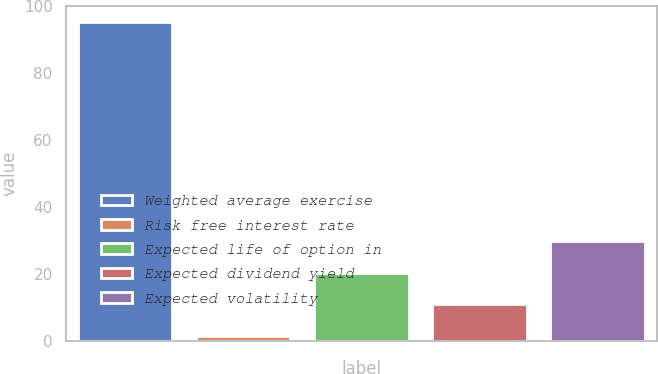Convert chart. <chart><loc_0><loc_0><loc_500><loc_500><bar_chart><fcel>Weighted average exercise<fcel>Risk free interest rate<fcel>Expected life of option in<fcel>Expected dividend yield<fcel>Expected volatility<nl><fcel>95.29<fcel>1.6<fcel>20.34<fcel>10.97<fcel>29.71<nl></chart> 